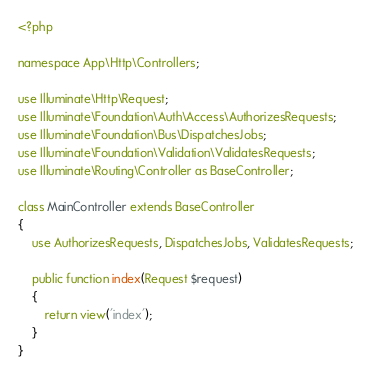Convert code to text. <code><loc_0><loc_0><loc_500><loc_500><_PHP_><?php

namespace App\Http\Controllers;

use Illuminate\Http\Request;
use Illuminate\Foundation\Auth\Access\AuthorizesRequests;
use Illuminate\Foundation\Bus\DispatchesJobs;
use Illuminate\Foundation\Validation\ValidatesRequests;
use Illuminate\Routing\Controller as BaseController;

class MainController extends BaseController
{
    use AuthorizesRequests, DispatchesJobs, ValidatesRequests;

    public function index(Request $request)
    {
        return view('index');
    }
}
</code> 